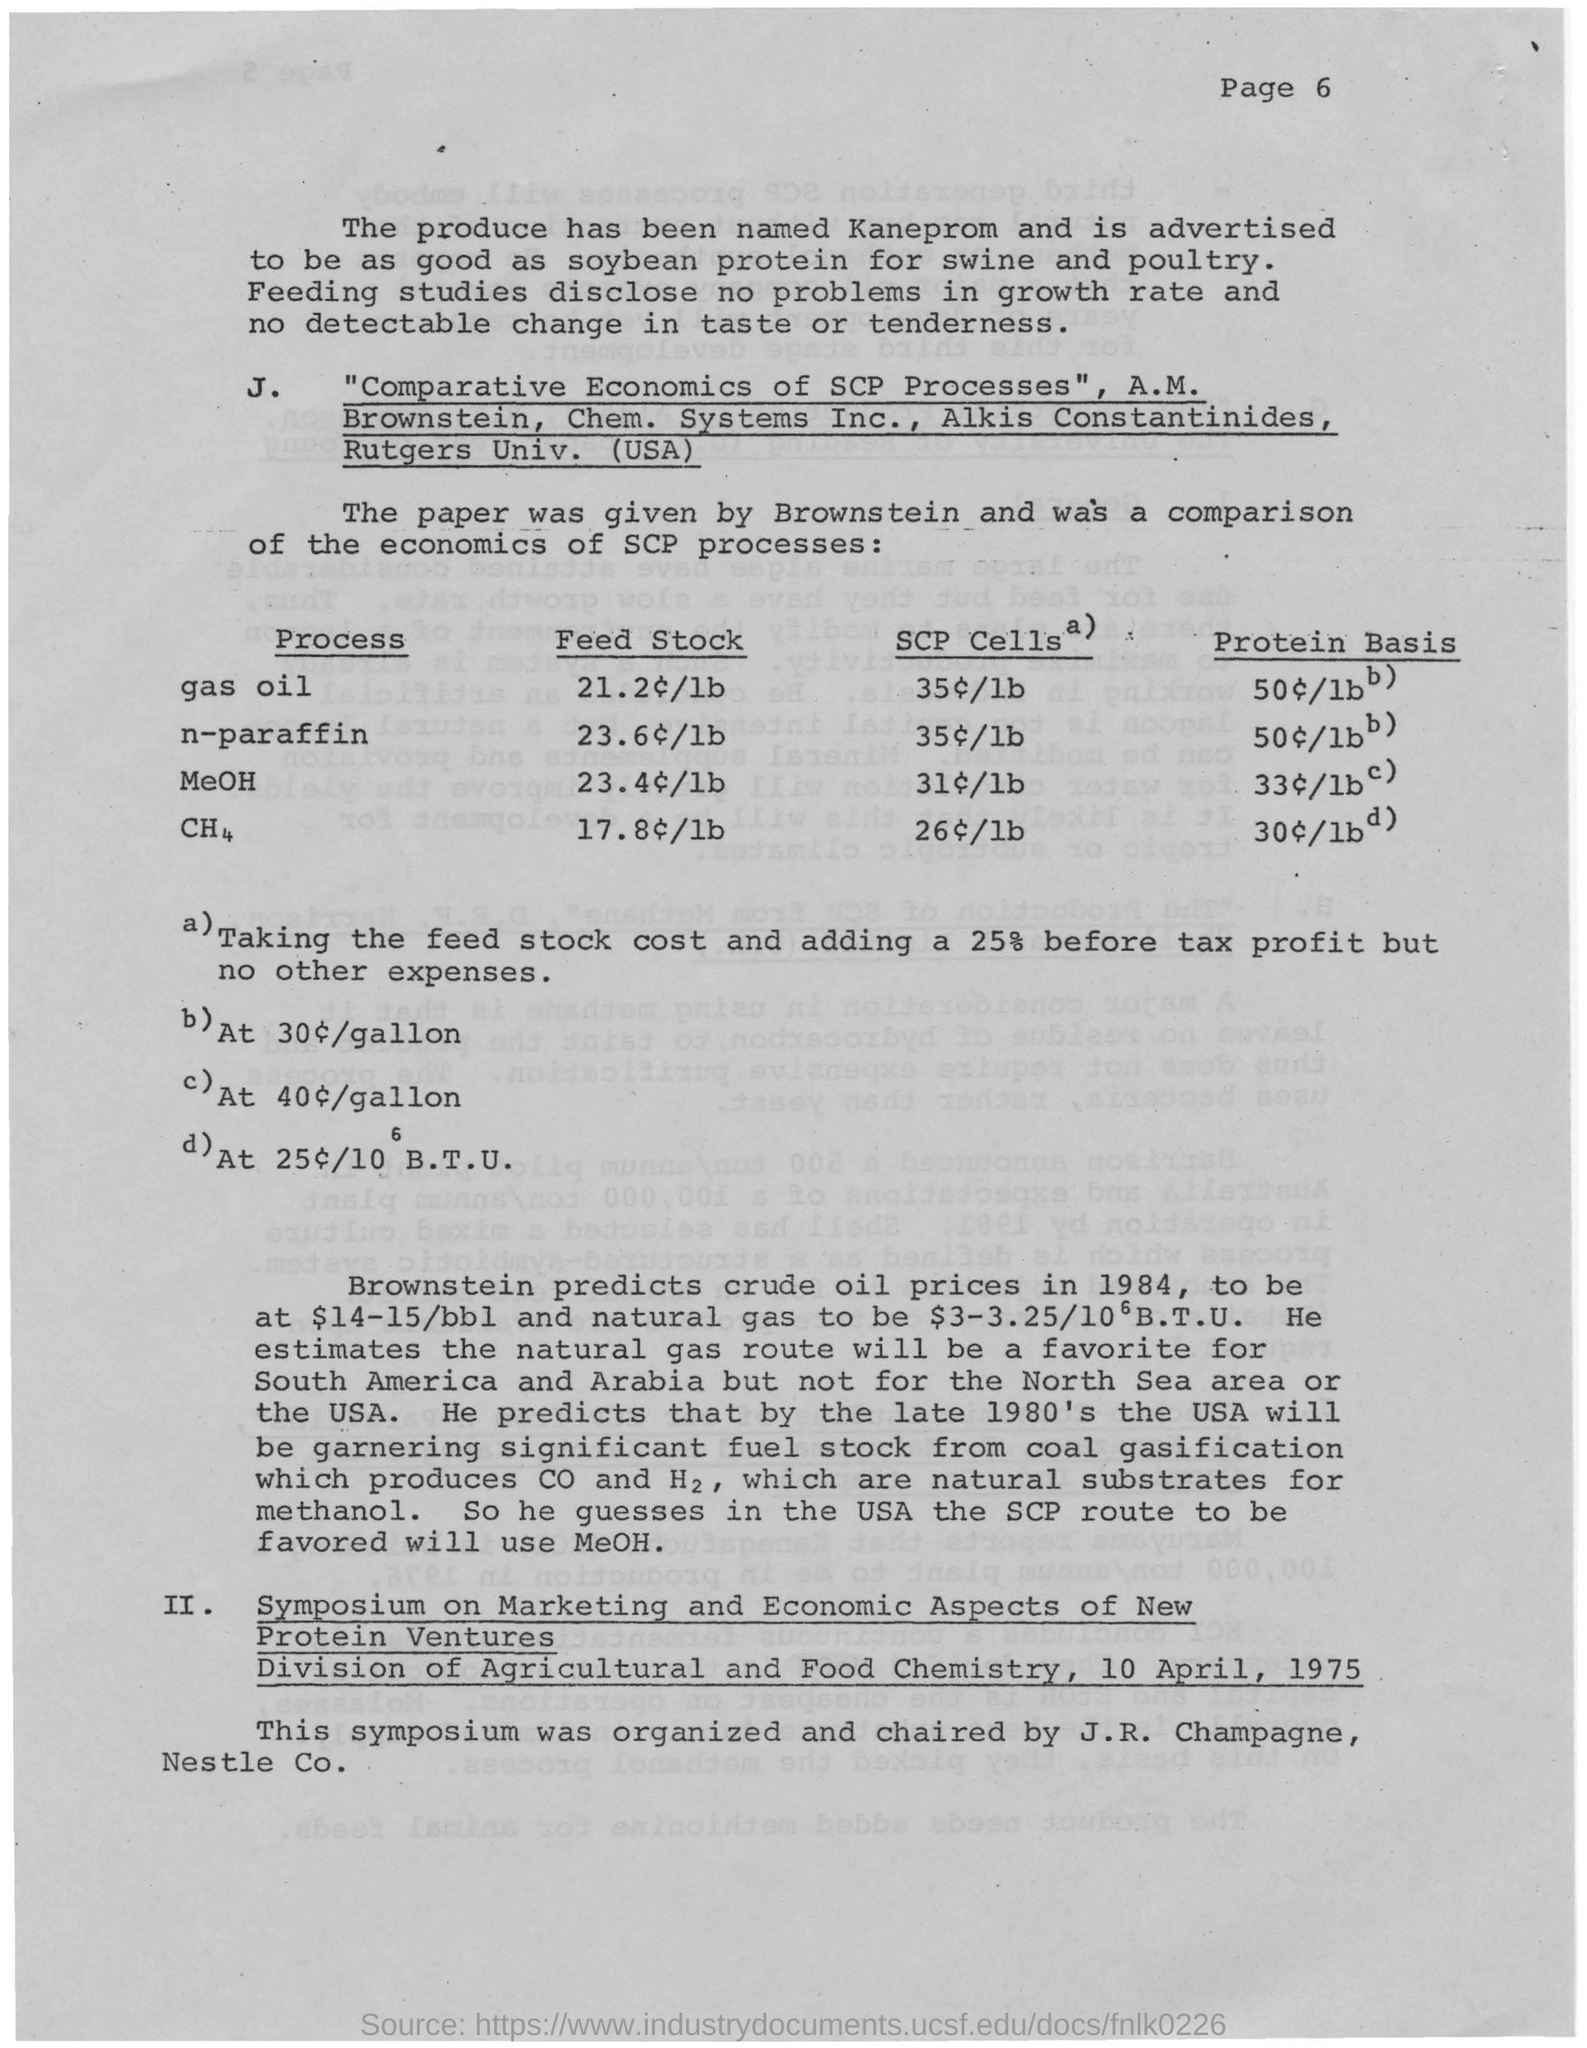Which page is this?
Offer a terse response. Page 6. What has the produce been named?
Make the answer very short. Kaneprom. What is the name of the paper by A.M. Brownstein?
Your response must be concise. "Comparative Economics of SCP Processes". How much does Brownstein predict crude oil prices in 1984?
Make the answer very short. $14-15/bbl. What is the symposium organized by Division of Agricultural and Food Chemistry?
Make the answer very short. Marketing and Economic Aspects of New Protein Ventures. When was the symposium?
Ensure brevity in your answer.  10 April, 1975. Who organized and chaired the symposium?
Give a very brief answer. J.R. Champagne. 